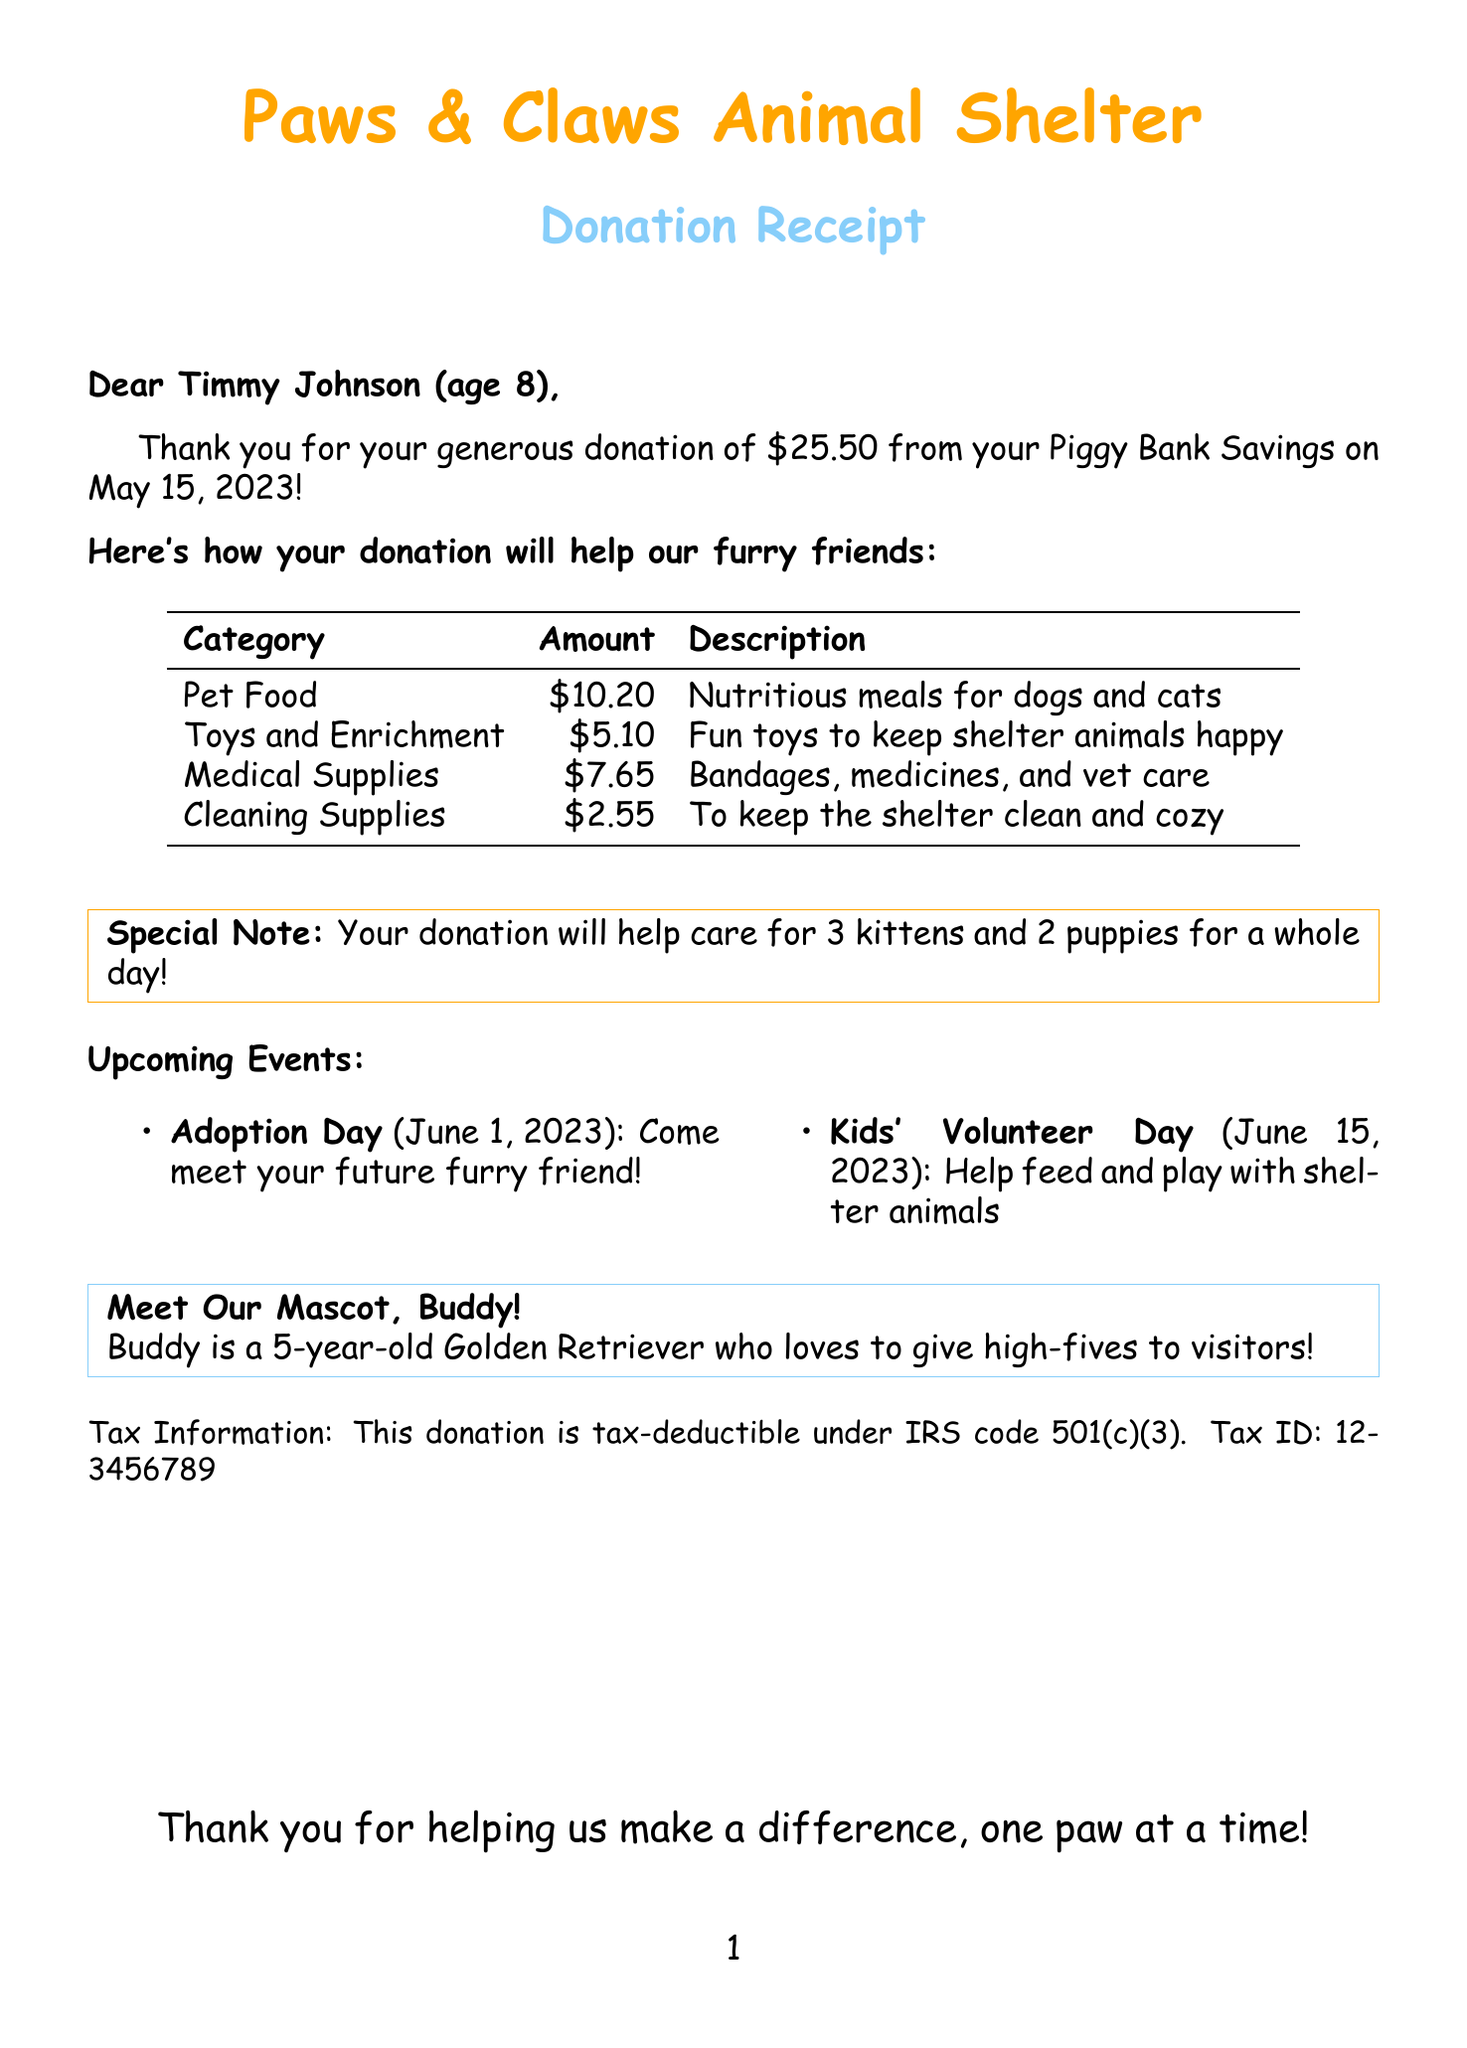What is the name of the animal shelter? The document states the name of the shelter at the beginning, which is "Paws & Claws Animal Shelter."
Answer: Paws & Claws Animal Shelter Who made the donation? The document lists the name of the donor, which is "Timmy Johnson."
Answer: Timmy Johnson What was the donation amount? The donation amount is clearly indicated in the document as $25.50.
Answer: $25.50 When was the donation made? The document specifies the donation date as May 15, 2023.
Answer: May 15, 2023 What will the donation help purchase for the animals? The breakdown includes "Pet Food," "Toys and Enrichment," "Medical Supplies," and "Cleaning Supplies," indicating how the funds will be used.
Answer: Pet Food, Toys and Enrichment, Medical Supplies, Cleaning Supplies How much will be spent on medical supplies? According to the breakdown provided in the document, the amount for medical supplies is $7.65.
Answer: $7.65 What is a special note mentioned in the document? The document contains a special note stating that the donation will help care for 3 kittens and 2 puppies for a whole day.
Answer: Your donation will help care for 3 kittens and 2 puppies for a whole day! What is the tax ID number? The document provides the tax ID number for tax purposes, which is "12-3456789."
Answer: 12-3456789 What is Buddy’s fun fact? The document includes a fun fact about the shelter mascot, Buddy, stating that "Buddy loves to give high-fives to visitors!"
Answer: Buddy loves to give high-fives to visitors! 